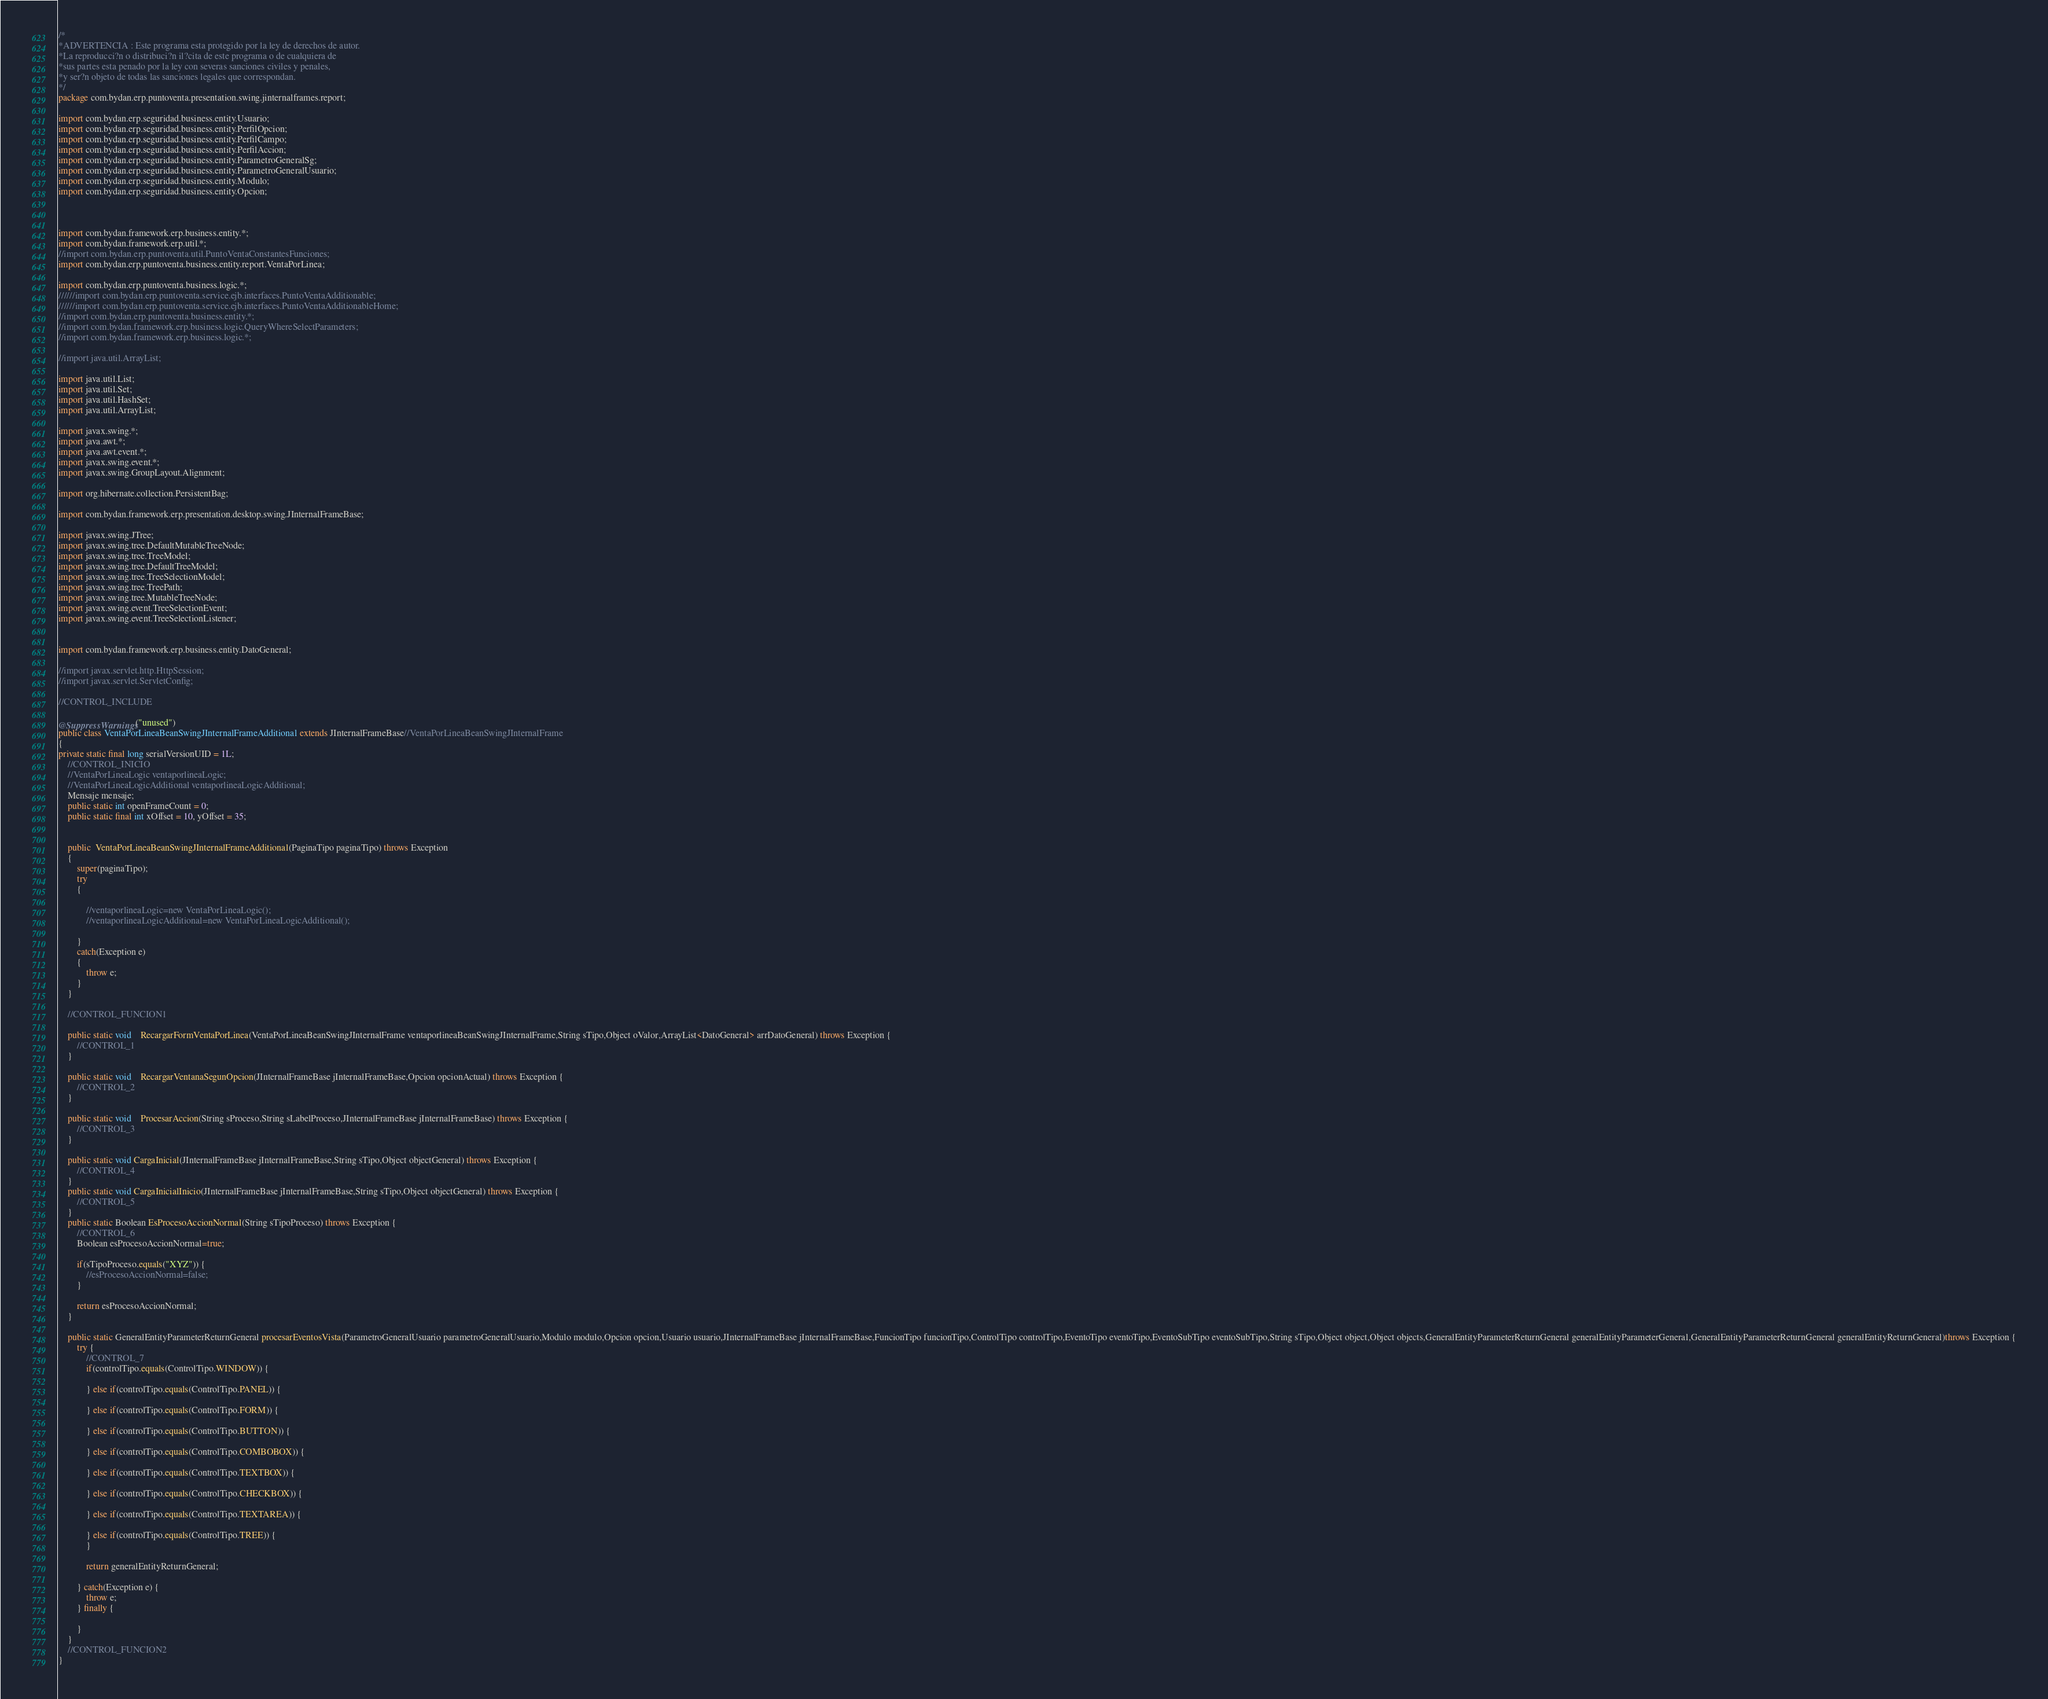<code> <loc_0><loc_0><loc_500><loc_500><_Java_>








/*
*ADVERTENCIA : Este programa esta protegido por la ley de derechos de autor.
*La reproducci?n o distribuci?n il?cita de este programa o de cualquiera de
*sus partes esta penado por la ley con severas sanciones civiles y penales,
*y ser?n objeto de todas las sanciones legales que correspondan.
*/
package com.bydan.erp.puntoventa.presentation.swing.jinternalframes.report;

import com.bydan.erp.seguridad.business.entity.Usuario;
import com.bydan.erp.seguridad.business.entity.PerfilOpcion;
import com.bydan.erp.seguridad.business.entity.PerfilCampo;
import com.bydan.erp.seguridad.business.entity.PerfilAccion;
import com.bydan.erp.seguridad.business.entity.ParametroGeneralSg;
import com.bydan.erp.seguridad.business.entity.ParametroGeneralUsuario;
import com.bydan.erp.seguridad.business.entity.Modulo;
import com.bydan.erp.seguridad.business.entity.Opcion;



import com.bydan.framework.erp.business.entity.*;
import com.bydan.framework.erp.util.*;
//import com.bydan.erp.puntoventa.util.PuntoVentaConstantesFunciones;
import com.bydan.erp.puntoventa.business.entity.report.VentaPorLinea;

import com.bydan.erp.puntoventa.business.logic.*;
//////import com.bydan.erp.puntoventa.service.ejb.interfaces.PuntoVentaAdditionable;
//////import com.bydan.erp.puntoventa.service.ejb.interfaces.PuntoVentaAdditionableHome;
//import com.bydan.erp.puntoventa.business.entity.*;
//import com.bydan.framework.erp.business.logic.QueryWhereSelectParameters;
//import com.bydan.framework.erp.business.logic.*;

//import java.util.ArrayList;

import java.util.List;
import java.util.Set;
import java.util.HashSet;
import java.util.ArrayList;

import javax.swing.*;
import java.awt.*;
import java.awt.event.*;
import javax.swing.event.*;
import javax.swing.GroupLayout.Alignment;

import org.hibernate.collection.PersistentBag;

import com.bydan.framework.erp.presentation.desktop.swing.JInternalFrameBase;

import javax.swing.JTree;
import javax.swing.tree.DefaultMutableTreeNode;
import javax.swing.tree.TreeModel;
import javax.swing.tree.DefaultTreeModel;
import javax.swing.tree.TreeSelectionModel;
import javax.swing.tree.TreePath;
import javax.swing.tree.MutableTreeNode;
import javax.swing.event.TreeSelectionEvent;
import javax.swing.event.TreeSelectionListener;


import com.bydan.framework.erp.business.entity.DatoGeneral;

//import javax.servlet.http.HttpSession;
//import javax.servlet.ServletConfig;

//CONTROL_INCLUDE

@SuppressWarnings("unused")
public class VentaPorLineaBeanSwingJInternalFrameAdditional extends JInternalFrameBase//VentaPorLineaBeanSwingJInternalFrame
{
private static final long serialVersionUID = 1L;
	//CONTROL_INICIO
	//VentaPorLineaLogic ventaporlineaLogic;
	//VentaPorLineaLogicAdditional ventaporlineaLogicAdditional;
	Mensaje mensaje;
	public static int openFrameCount = 0;
    public static final int xOffset = 10, yOffset = 35;
	
	
	public  VentaPorLineaBeanSwingJInternalFrameAdditional(PaginaTipo paginaTipo) throws Exception
	{
		super(paginaTipo);
		try 
		{			
			
			//ventaporlineaLogic=new VentaPorLineaLogic();
			//ventaporlineaLogicAdditional=new VentaPorLineaLogicAdditional();
			
		} 		
		catch(Exception e)
		{
			throw e;
		}
    } 	
	
	//CONTROL_FUNCION1
	
	public static void	RecargarFormVentaPorLinea(VentaPorLineaBeanSwingJInternalFrame ventaporlineaBeanSwingJInternalFrame,String sTipo,Object oValor,ArrayList<DatoGeneral> arrDatoGeneral) throws Exception {	
		//CONTROL_1
	}
	
	public static void	RecargarVentanaSegunOpcion(JInternalFrameBase jInternalFrameBase,Opcion opcionActual) throws Exception {	
		//CONTROL_2
	}
	
	public static void	ProcesarAccion(String sProceso,String sLabelProceso,JInternalFrameBase jInternalFrameBase) throws Exception {
		//CONTROL_3
	}

	public static void CargaInicial(JInternalFrameBase jInternalFrameBase,String sTipo,Object objectGeneral) throws Exception {
		//CONTROL_4
	}
	public static void CargaInicialInicio(JInternalFrameBase jInternalFrameBase,String sTipo,Object objectGeneral) throws Exception {
		//CONTROL_5
	}
	public static Boolean EsProcesoAccionNormal(String sTipoProceso) throws Exception {
		//CONTROL_6
		Boolean esProcesoAccionNormal=true;

		if(sTipoProceso.equals("XYZ")) {
			//esProcesoAccionNormal=false;
		}

		return esProcesoAccionNormal;
	}

	public static GeneralEntityParameterReturnGeneral procesarEventosVista(ParametroGeneralUsuario parametroGeneralUsuario,Modulo modulo,Opcion opcion,Usuario usuario,JInternalFrameBase jInternalFrameBase,FuncionTipo funcionTipo,ControlTipo controlTipo,EventoTipo eventoTipo,EventoSubTipo eventoSubTipo,String sTipo,Object object,Object objects,GeneralEntityParameterReturnGeneral generalEntityParameterGeneral,GeneralEntityParameterReturnGeneral generalEntityReturnGeneral)throws Exception {
		try {
			//CONTROL_7
			if(controlTipo.equals(ControlTipo.WINDOW)) {

			} else if(controlTipo.equals(ControlTipo.PANEL)) {

			} else if(controlTipo.equals(ControlTipo.FORM)) {

			} else if(controlTipo.equals(ControlTipo.BUTTON)) {

			} else if(controlTipo.equals(ControlTipo.COMBOBOX)) {

			} else if(controlTipo.equals(ControlTipo.TEXTBOX)) {

			} else if(controlTipo.equals(ControlTipo.CHECKBOX)) {

			} else if(controlTipo.equals(ControlTipo.TEXTAREA)) {

			} else if(controlTipo.equals(ControlTipo.TREE)) {
			}

			return generalEntityReturnGeneral;

		} catch(Exception e) {
			throw e;
		} finally {

		}
	}
	//CONTROL_FUNCION2
}</code> 